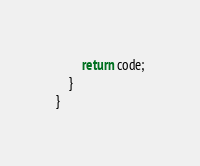Convert code to text. <code><loc_0><loc_0><loc_500><loc_500><_Java_>        return code;
    }
}
</code> 